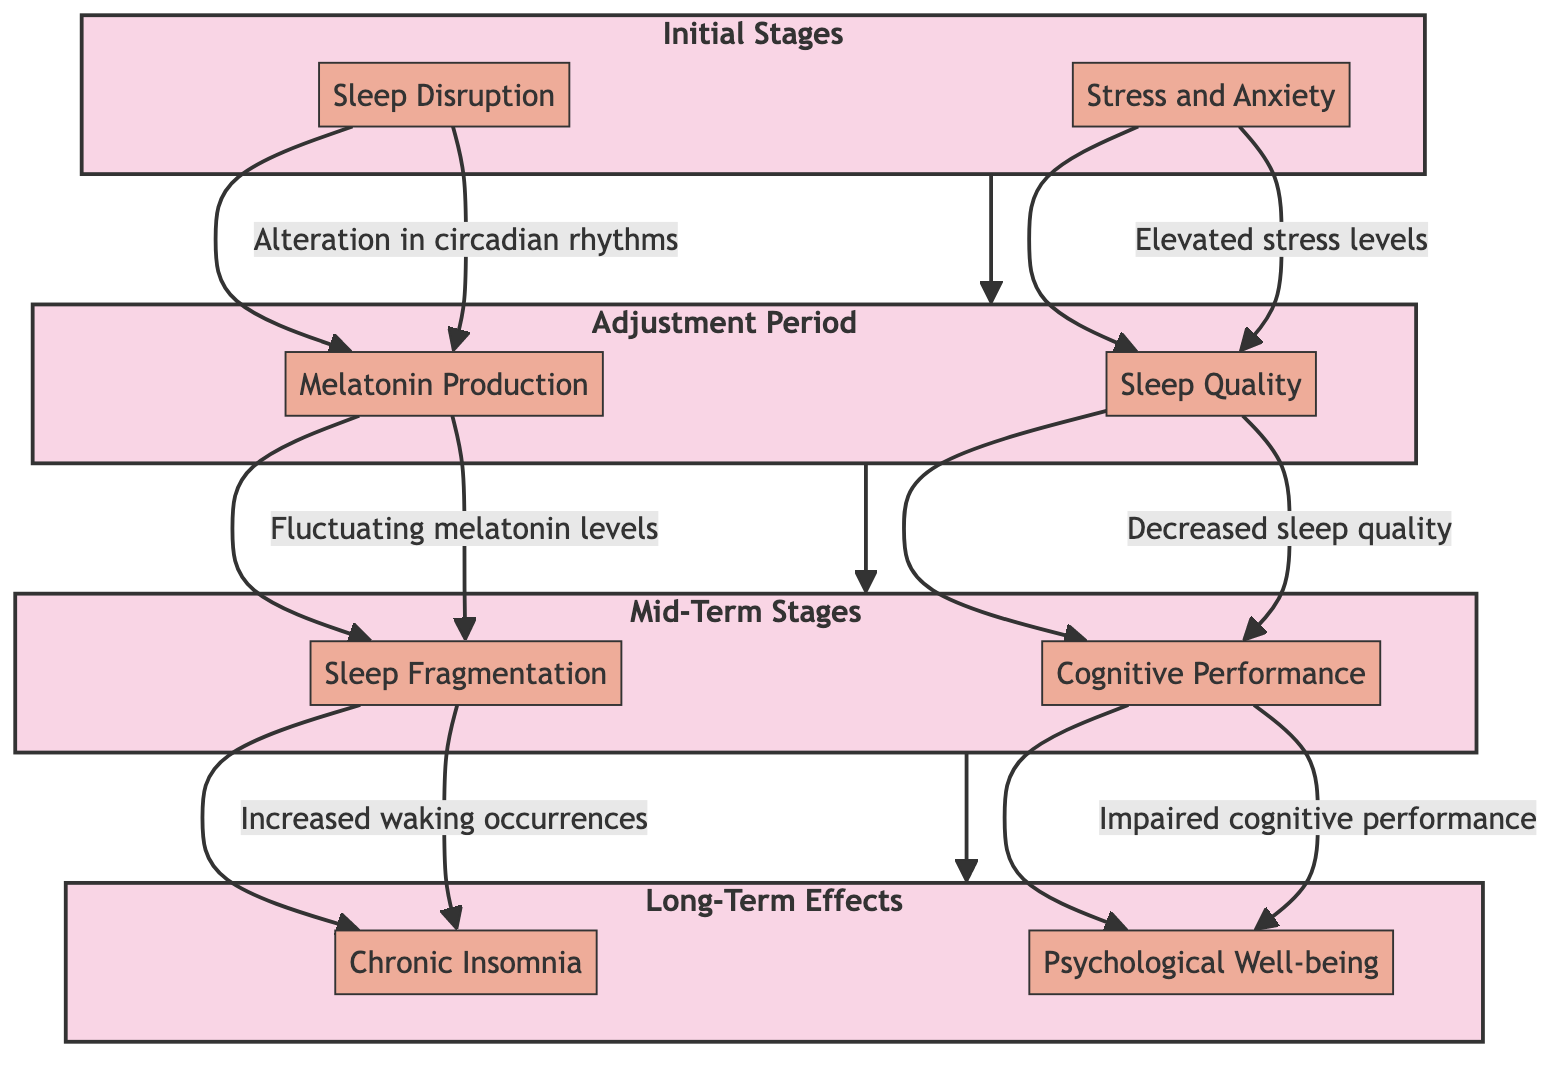What is the first stage depicted in the diagram? The diagram starts with the 'Initial Stages', which is the first stage that leads to subsequent effects.
Answer: Initial Stages How many main stages are represented in the diagram? There are four main stages represented: Initial Stages, Adjustment Period, Mid-Term Stages, and Long-Term Effects.
Answer: Four What aspect affects sleep quality in the Adjustment Period? In the Adjustment Period, 'Sleep Quality' is an aspect that reflects a decrease in overall sleep quality despite controlled conditions.
Answer: Sleep Quality Which long-term effect is associated with chronic disorders? The aspect 'Chronic Insomnia' in the Long-Term Effects stage relates to developing long-term sleep disorders due to prolonged isolation.
Answer: Chronic Insomnia What aspect in the Initial Stages is related to stress levels? The aspect 'Stress and Anxiety' addresses elevated stress levels in the Initial Stages which impact sleep.
Answer: Stress and Anxiety How does 'Sleep Fragmentation' in Mid-Term Stages impact cognitive performance? 'Sleep Fragmentation' leads to 'Impaired cognitive performance', indicating that disruptions in sleep during the Mid-Term Stages negatively affect cognitive abilities.
Answer: Impaired cognitive performance What follows after the Adjustment Period in the diagram flow? The flow continues from the Adjustment Period to the Mid-Term Stages, indicating that the effects are sequential in nature.
Answer: Mid-Term Stages Which specific aspect has a direct relationship to sleep disruption during the Initial Stages? 'Sleep Disruption' is directly connected to changes in circadian rhythms that occur because of the absence of natural light in the Initial Stages.
Answer: Sleep Disruption In Long-Term Effects, which psychological aspect is linked to poor sleep? The aspect 'Psychological Well-being' connects to diminished well-being and potential for depression due to long-term poor sleep.
Answer: Psychological Well-being 